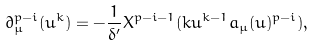Convert formula to latex. <formula><loc_0><loc_0><loc_500><loc_500>\partial _ { \mu } ^ { p - i } ( u ^ { k } ) = - \frac { 1 } { \delta ^ { \prime } } X ^ { p - i - 1 } ( k u ^ { k - 1 } a _ { \mu } ( u ) ^ { p - i } ) ,</formula> 